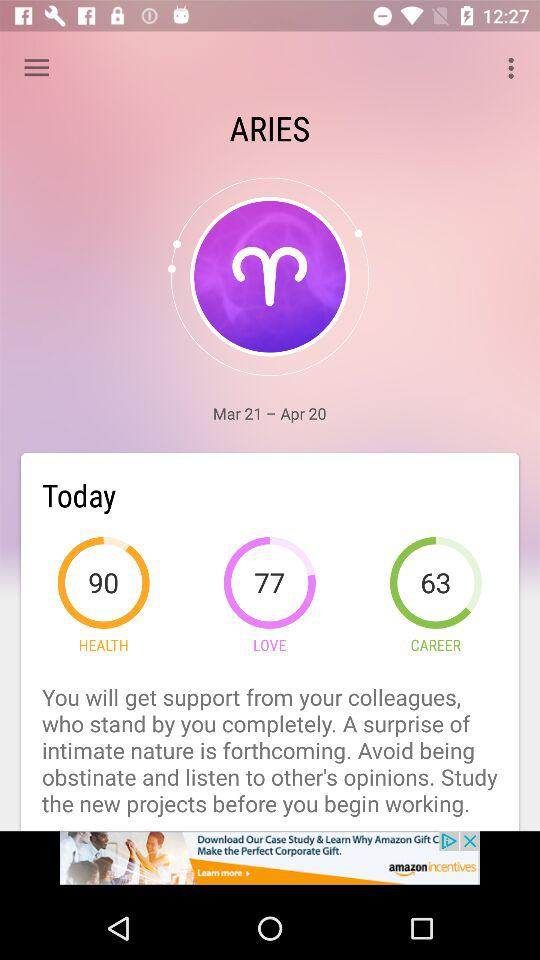What is today's health percentage? Today's health percentage is 90. 